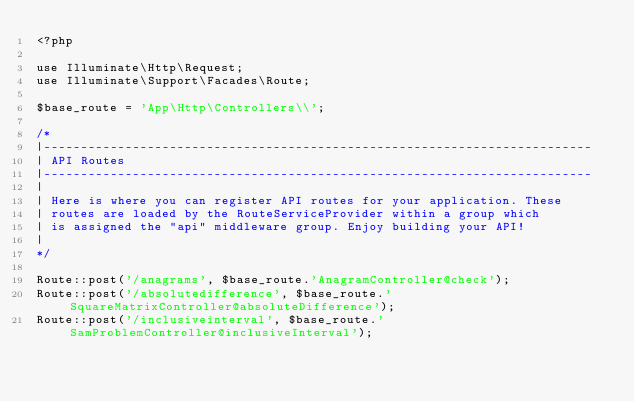<code> <loc_0><loc_0><loc_500><loc_500><_PHP_><?php

use Illuminate\Http\Request;
use Illuminate\Support\Facades\Route;

$base_route = 'App\Http\Controllers\\';

/*
|--------------------------------------------------------------------------
| API Routes
|--------------------------------------------------------------------------
|
| Here is where you can register API routes for your application. These
| routes are loaded by the RouteServiceProvider within a group which
| is assigned the "api" middleware group. Enjoy building your API!
|
*/

Route::post('/anagrams', $base_route.'AnagramController@check');
Route::post('/absolutedifference', $base_route.'SquareMatrixController@absoluteDifference');
Route::post('/inclusiveinterval', $base_route.'SamProblemController@inclusiveInterval');
</code> 